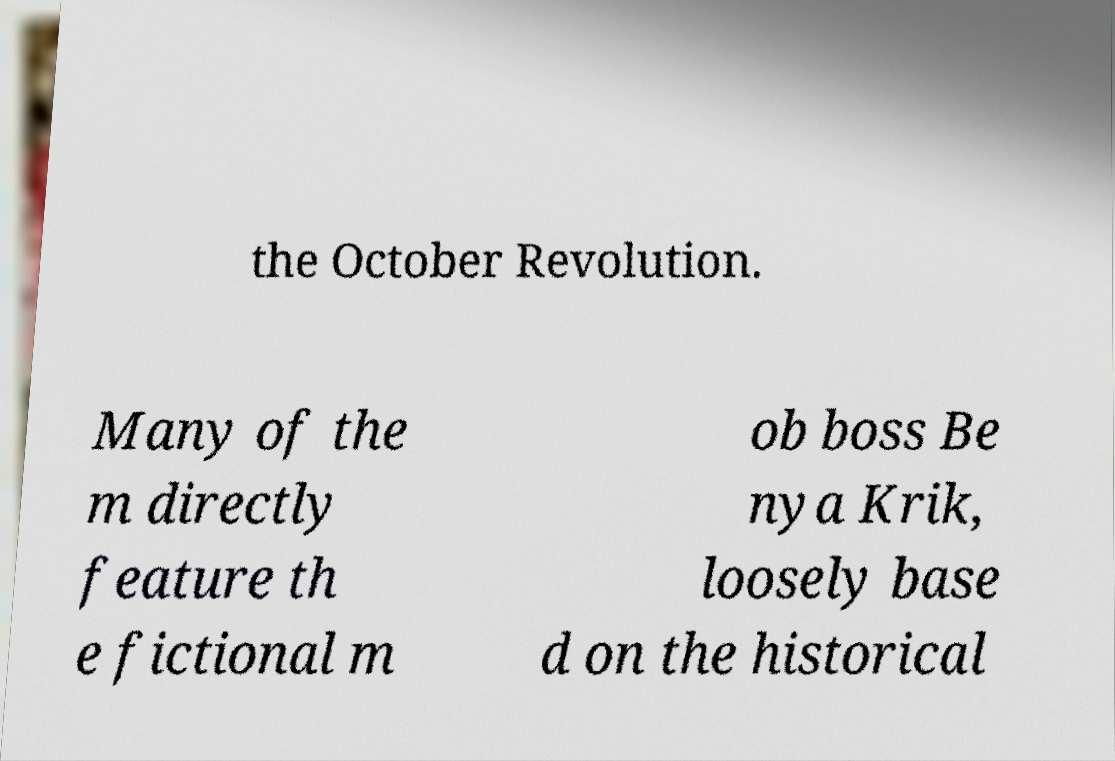Could you assist in decoding the text presented in this image and type it out clearly? the October Revolution. Many of the m directly feature th e fictional m ob boss Be nya Krik, loosely base d on the historical 